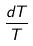Convert formula to latex. <formula><loc_0><loc_0><loc_500><loc_500>\frac { d T } { T }</formula> 